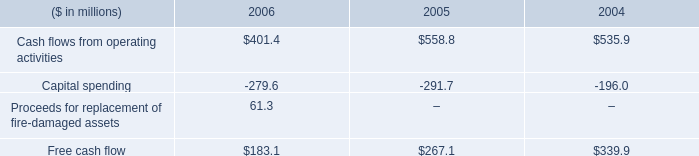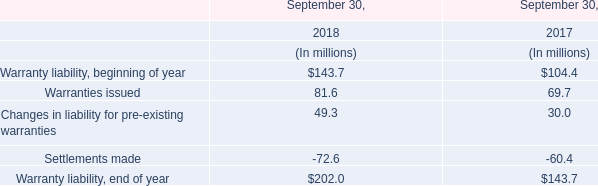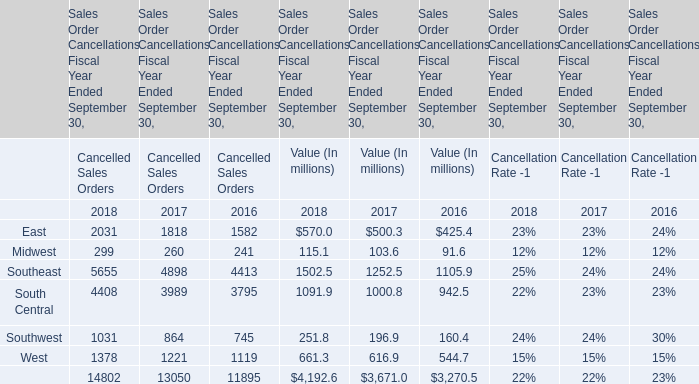What is the average value of Cancelled Sales Orders in 2018, 2017, and 2016? (in million) 
Computations: (((4192.6 + 3671.0) + 3270.5) / 3)
Answer: 3711.36667. 